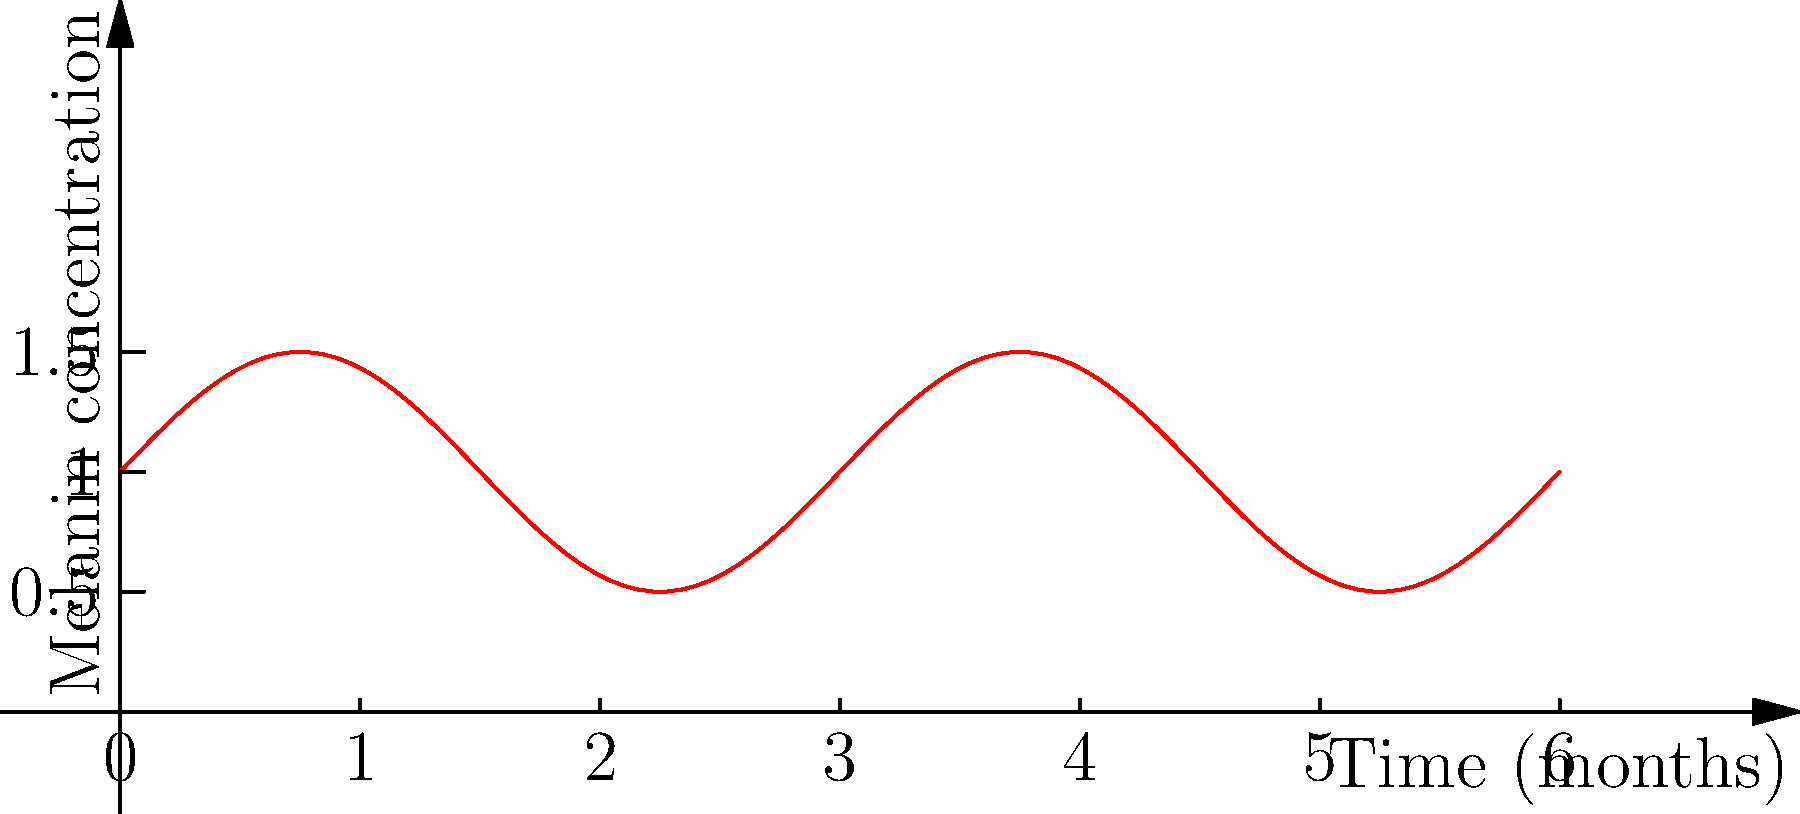In your research on feline coat color genetics, you've discovered that melanin concentration in developing hair follicles follows a sinusoidal pattern over time. This pattern is represented by the function $M(t) = 0.5\sin(\frac{2\pi t}{3}) + 1$, where $M$ is the melanin concentration and $t$ is time in months. Based on the graph, at what time (in months) does the melanin concentration first reach its maximum value? To solve this problem, we need to follow these steps:

1) The maximum value of a sine function occurs when its argument is $\frac{\pi}{2}$ (or 90 degrees).

2) In our function $M(t) = 0.5\sin(\frac{2\pi t}{3}) + 1$, the argument of sine is $\frac{2\pi t}{3}$.

3) We need to find $t$ when $\frac{2\pi t}{3} = \frac{\pi}{2}$.

4) Solving this equation:
   $\frac{2\pi t}{3} = \frac{\pi}{2}$
   $2\pi t = \frac{3\pi}{2}$
   $t = \frac{3}{4}$

5) Therefore, the melanin concentration reaches its first maximum at $t = \frac{3}{4}$ months.

6) We can verify this on the graph: the first peak occurs between 0 and 1, specifically at 0.75 months.

This cycle repeats every 3 months, which aligns with the growth cycle of cat hair follicles.
Answer: $\frac{3}{4}$ months 